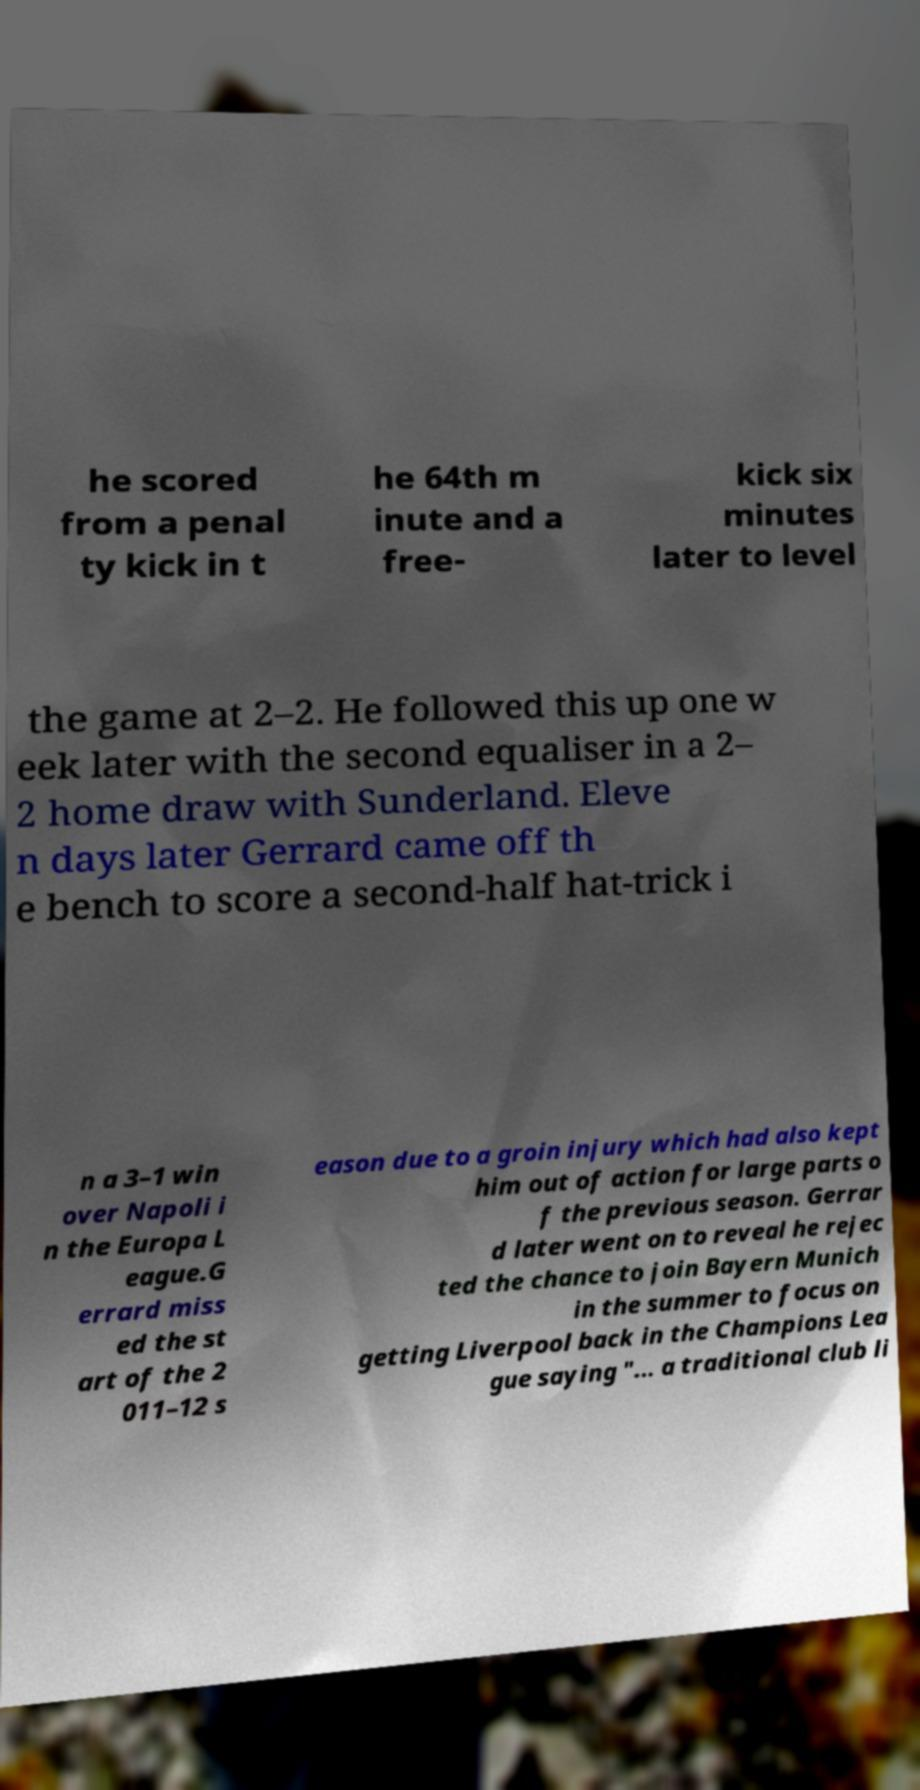Please identify and transcribe the text found in this image. he scored from a penal ty kick in t he 64th m inute and a free- kick six minutes later to level the game at 2–2. He followed this up one w eek later with the second equaliser in a 2– 2 home draw with Sunderland. Eleve n days later Gerrard came off th e bench to score a second-half hat-trick i n a 3–1 win over Napoli i n the Europa L eague.G errard miss ed the st art of the 2 011–12 s eason due to a groin injury which had also kept him out of action for large parts o f the previous season. Gerrar d later went on to reveal he rejec ted the chance to join Bayern Munich in the summer to focus on getting Liverpool back in the Champions Lea gue saying "... a traditional club li 